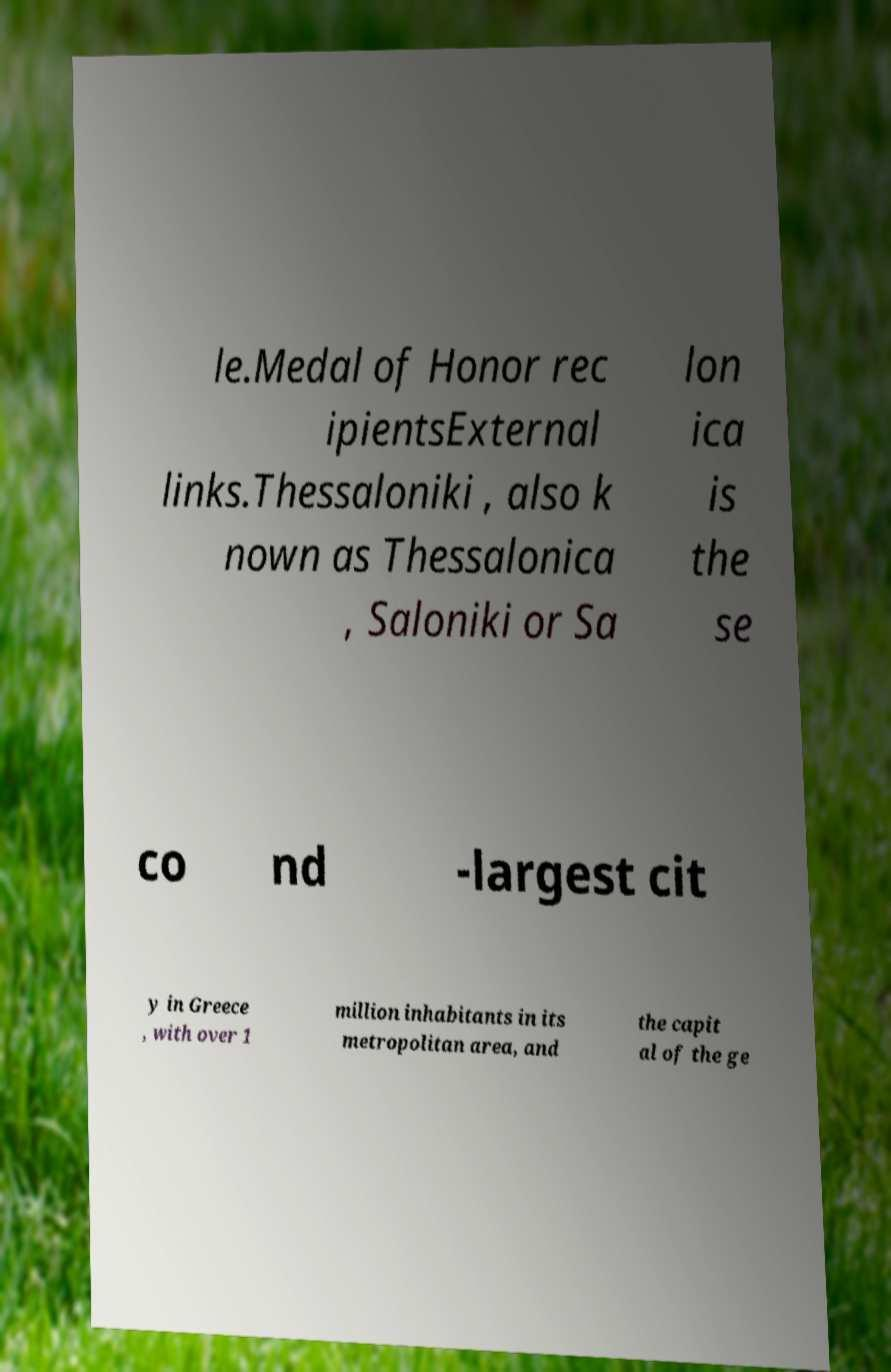Could you extract and type out the text from this image? le.Medal of Honor rec ipientsExternal links.Thessaloniki , also k nown as Thessalonica , Saloniki or Sa lon ica is the se co nd -largest cit y in Greece , with over 1 million inhabitants in its metropolitan area, and the capit al of the ge 